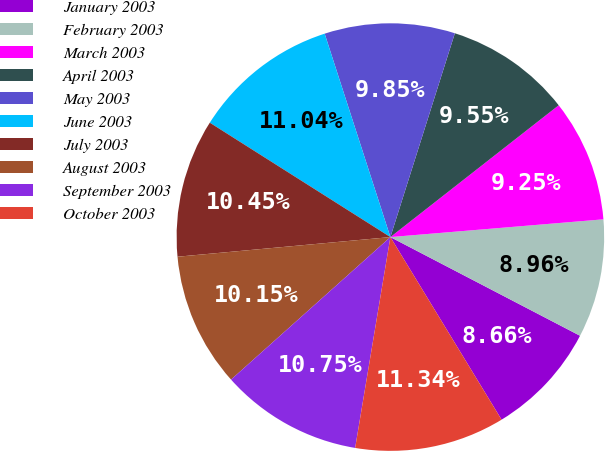Convert chart. <chart><loc_0><loc_0><loc_500><loc_500><pie_chart><fcel>January 2003<fcel>February 2003<fcel>March 2003<fcel>April 2003<fcel>May 2003<fcel>June 2003<fcel>July 2003<fcel>August 2003<fcel>September 2003<fcel>October 2003<nl><fcel>8.66%<fcel>8.96%<fcel>9.25%<fcel>9.55%<fcel>9.85%<fcel>11.04%<fcel>10.45%<fcel>10.15%<fcel>10.75%<fcel>11.34%<nl></chart> 